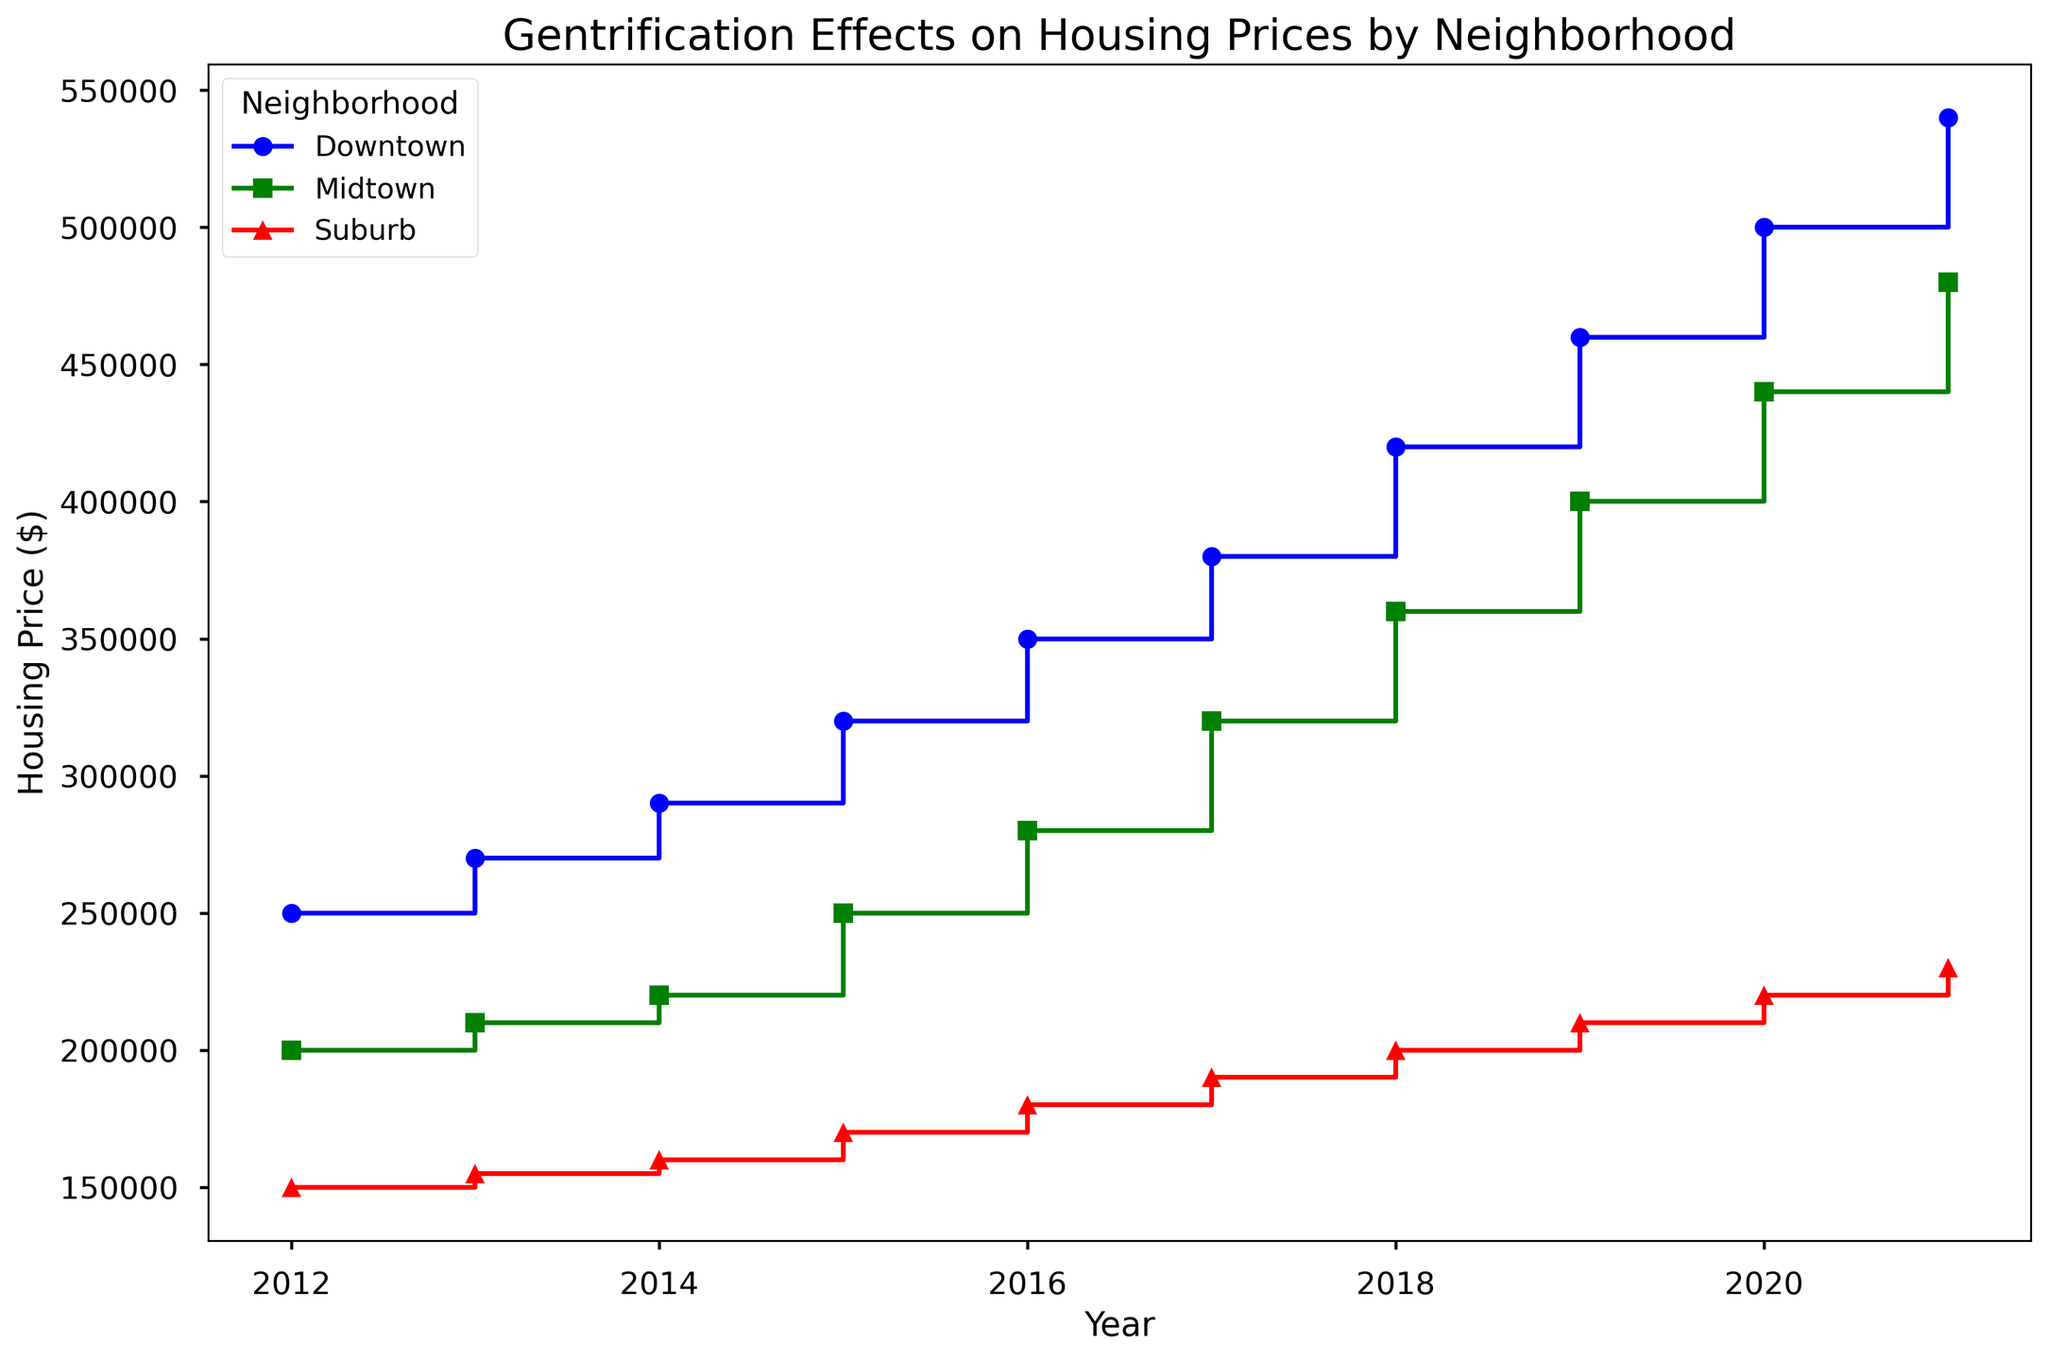How much did housing prices increase in Downtown from 2012 to 2016? To find the increase in housing prices in Downtown from 2012 to 2016, subtract the 2012 housing price from the 2016 housing price. That is, $350,000 (2016 price) - $250,000 (2012 price) = $100,000.
Answer: $100,000 Which neighborhood had the highest housing price in 2020? Compare the housing prices for each neighborhood in 2020: Downtown ($500,000), Midtown ($440,000), Suburb ($220,000). Downtown has the highest price.
Answer: Downtown How does the housing price trend in Downtown compare to the trend in the Suburb? Look at the slope of the lines representing Downtown and Suburb. Downtown shows a steep increase in housing prices each year, while Suburb has a more gradual increase.
Answer: Downtown has a steeper increase Between which two consecutive years did Midtown experience the largest increase in housing prices? Calculate the increase in housing prices for Midtown between consecutive years. The largest increase is between 2016 and 2017, from $280,000 to $320,000 ($40,000 increase).
Answer: 2016-2017 What was the average housing price in Midtown over the years 2017 to 2021? Sum the housing prices for Midtown from 2017 to 2021 ($320,000 + $360,000 + $400,000 + $440,000 + $480,000) and divide by the number of years (5). The total is $2,000,000, so the average is $2,000,000 / 5 = $400,000.
Answer: $400,000 Which neighborhood saw the least variation in housing prices over the years? Evaluate the range (difference between highest and lowest prices) of each neighborhood. Suburb ranges from $150,000 to $230,000, Downtown ranges from $250,000 to $540,000, and Midtown ranges from $200,000 to $480,000. Suburb had the least variation.
Answer: Suburb By what percentage did the housing price in Downtown increase from 2018 to 2021? First, find the difference between the housing prices in 2018 and 2021: $540,000 - $420,000 = $120,000. Then, divide this difference by the 2018 price and multiply by 100: ($120,000 / $420,000) * 100 ≈ 28.57%.
Answer: 28.57% How does the absolute increase in housing prices from 2012 to 2021 in Suburb compare to Midtown? Calculate the increase for each: Suburb ($230,000 - $150,000 = $80,000) and Midtown ($480,000 - $200,000 = $280,000). Midtown's increase is greater.
Answer: Midtown's increase is greater In what year did housing prices in Midtown first exceed $300,000? Look at the plotted points for Midtown and find the first year the housing price was above $300,000. In 2017, the price reaches $320,000.
Answer: 2017 Compare the housing price trends between Downtown and Midtown over the entire period. Both neighborhoods show increasing trends, but Downtown increases more steeply and starts at a higher price. Midtown starts lower and increases moderately.
Answer: Downtown increases more steeply 